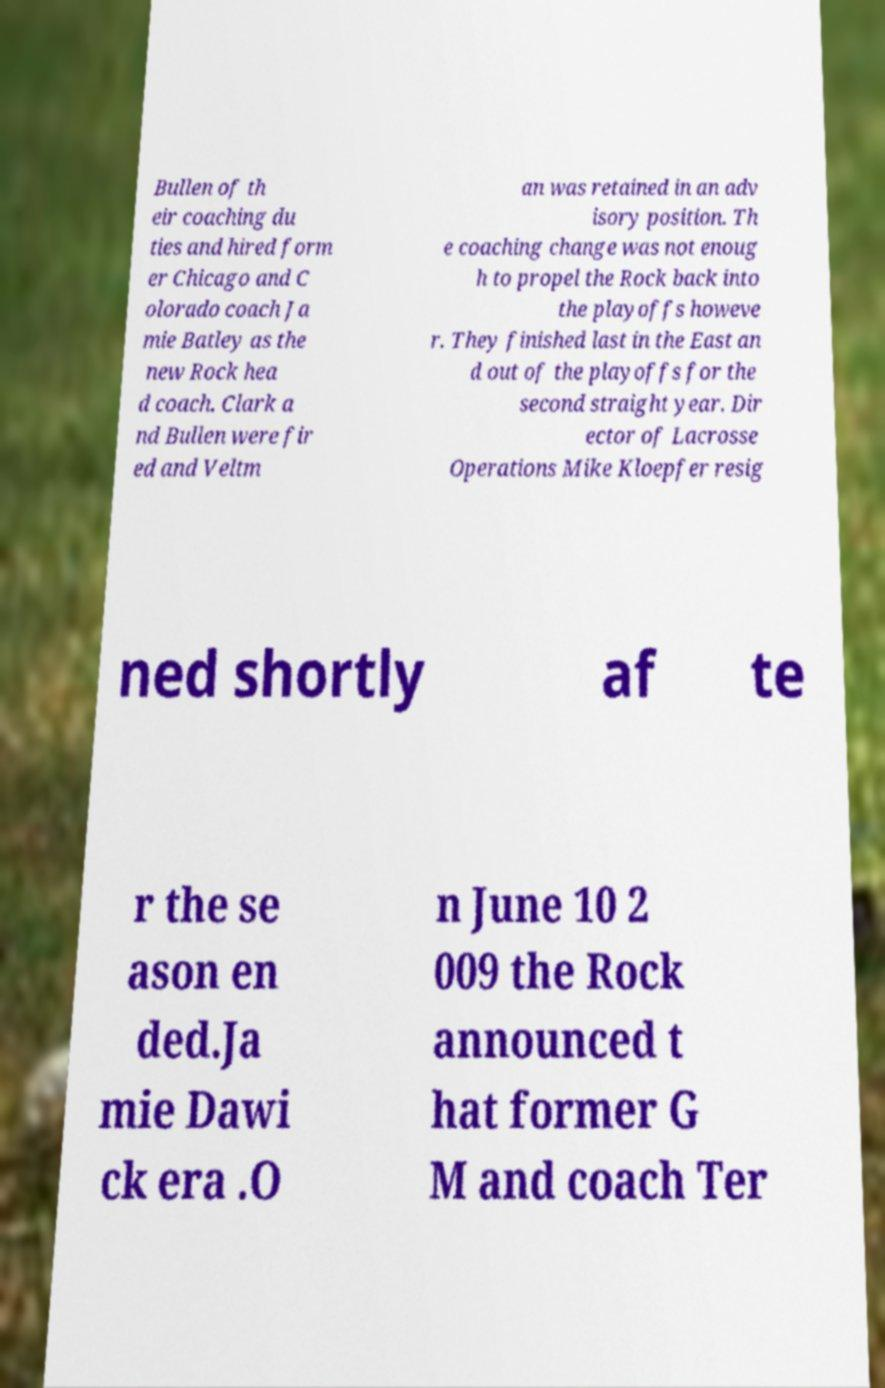For documentation purposes, I need the text within this image transcribed. Could you provide that? Bullen of th eir coaching du ties and hired form er Chicago and C olorado coach Ja mie Batley as the new Rock hea d coach. Clark a nd Bullen were fir ed and Veltm an was retained in an adv isory position. Th e coaching change was not enoug h to propel the Rock back into the playoffs howeve r. They finished last in the East an d out of the playoffs for the second straight year. Dir ector of Lacrosse Operations Mike Kloepfer resig ned shortly af te r the se ason en ded.Ja mie Dawi ck era .O n June 10 2 009 the Rock announced t hat former G M and coach Ter 